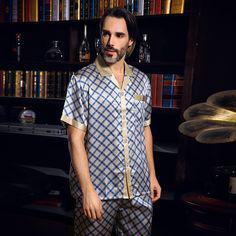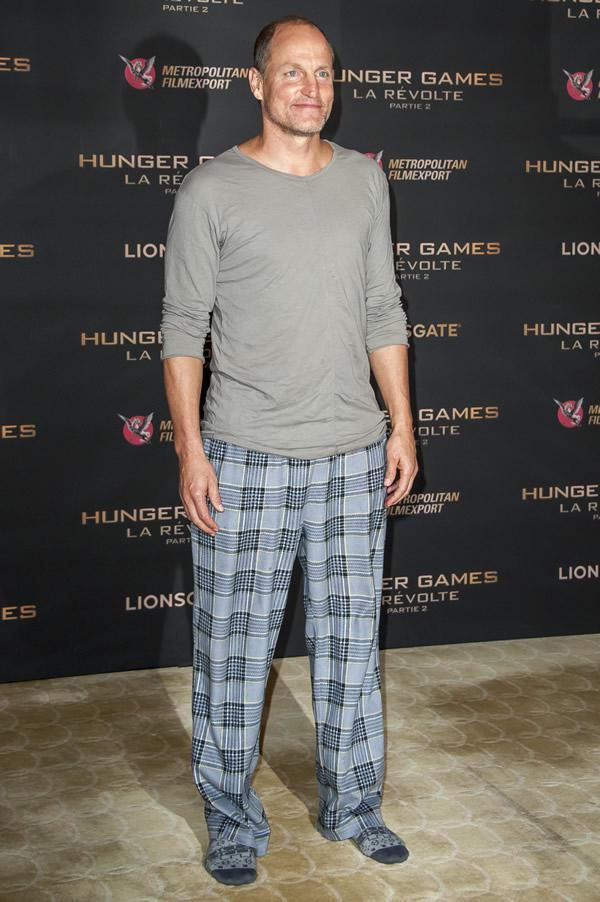The first image is the image on the left, the second image is the image on the right. Evaluate the accuracy of this statement regarding the images: "A man's silky diamond design pajama shirt has contrasting color at the collar, sleeve cuffs and pocket edge.". Is it true? Answer yes or no. Yes. The first image is the image on the left, the second image is the image on the right. Assess this claim about the two images: "A man is wearing plaid pajama pants in the image on the right.". Correct or not? Answer yes or no. Yes. 